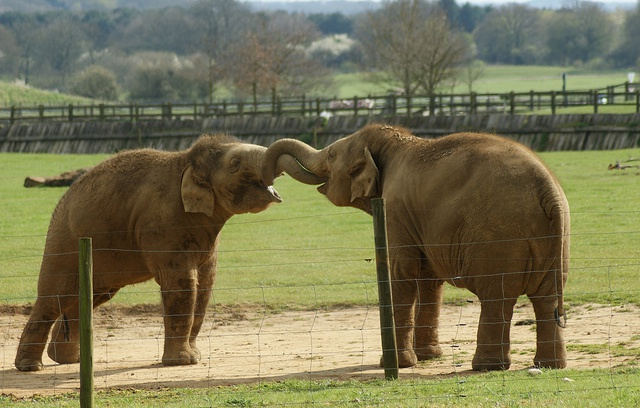Describe the objects in this image and their specific colors. I can see elephant in darkgray, black, gray, and tan tones and elephant in darkgray, maroon, black, and tan tones in this image. 